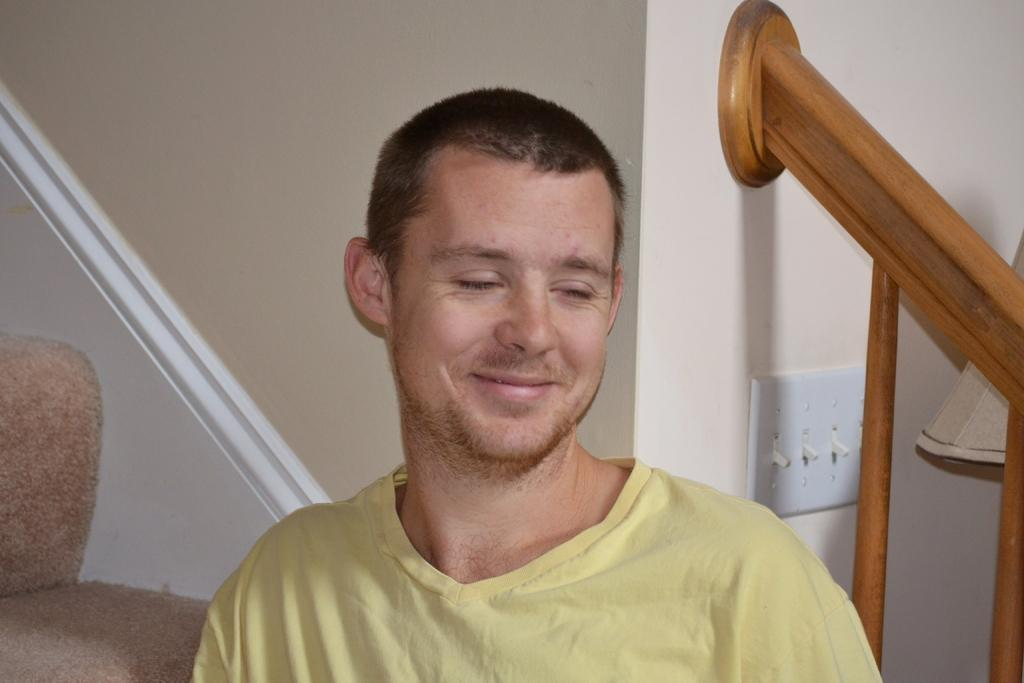What is the main subject in the foreground of the image? There is a man in the foreground of the image. What architectural feature can be seen in the background of the image? There are stairs in the background of the image. What objects are present in the background of the image? There are switches and a lamp in the background of the image. What type of skin can be seen on the toad in the image? There is no toad present in the image, so there is no skin to describe. 